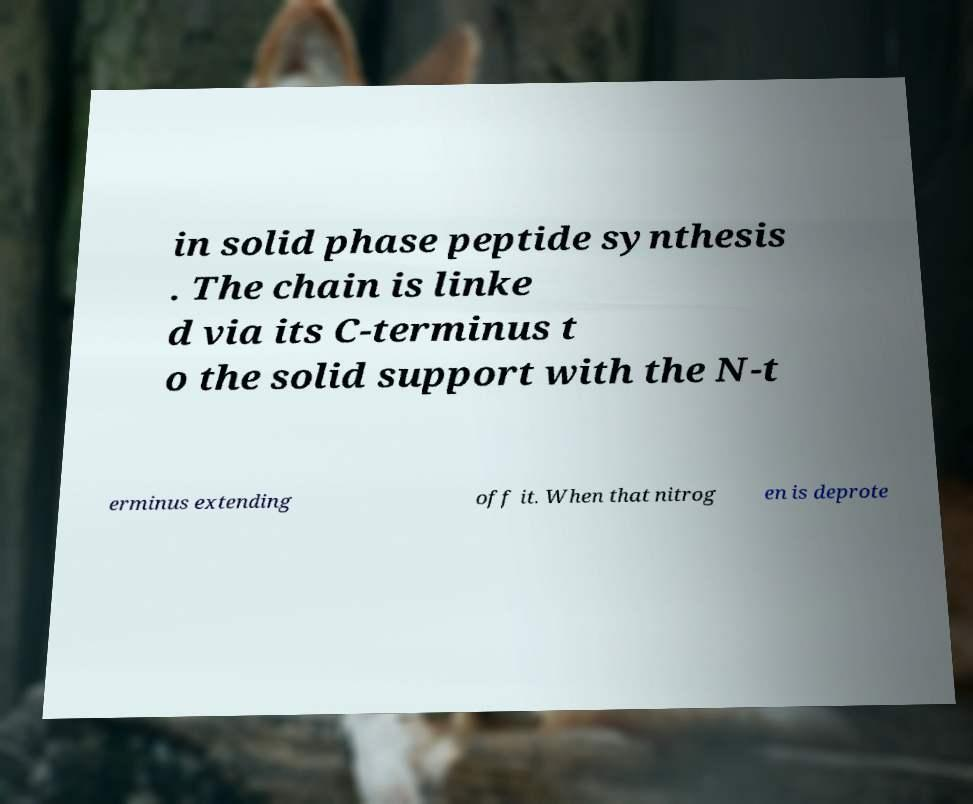Please read and relay the text visible in this image. What does it say? in solid phase peptide synthesis . The chain is linke d via its C-terminus t o the solid support with the N-t erminus extending off it. When that nitrog en is deprote 